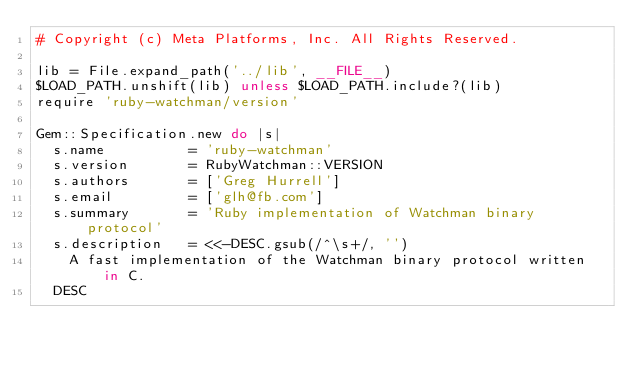Convert code to text. <code><loc_0><loc_0><loc_500><loc_500><_Ruby_># Copyright (c) Meta Platforms, Inc. All Rights Reserved.

lib = File.expand_path('../lib', __FILE__)
$LOAD_PATH.unshift(lib) unless $LOAD_PATH.include?(lib)
require 'ruby-watchman/version'

Gem::Specification.new do |s|
  s.name          = 'ruby-watchman'
  s.version       = RubyWatchman::VERSION
  s.authors       = ['Greg Hurrell']
  s.email         = ['glh@fb.com']
  s.summary       = 'Ruby implementation of Watchman binary protocol'
  s.description   = <<-DESC.gsub(/^\s+/, '')
    A fast implementation of the Watchman binary protocol written in C.
  DESC</code> 